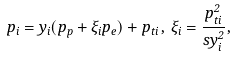<formula> <loc_0><loc_0><loc_500><loc_500>p _ { i } = y _ { i } ( p _ { p } + \xi _ { i } p _ { e } ) + p _ { t i } \, , \, \xi _ { i } = \frac { p _ { t i } ^ { 2 } } { s y _ { i } ^ { 2 } } ,</formula> 